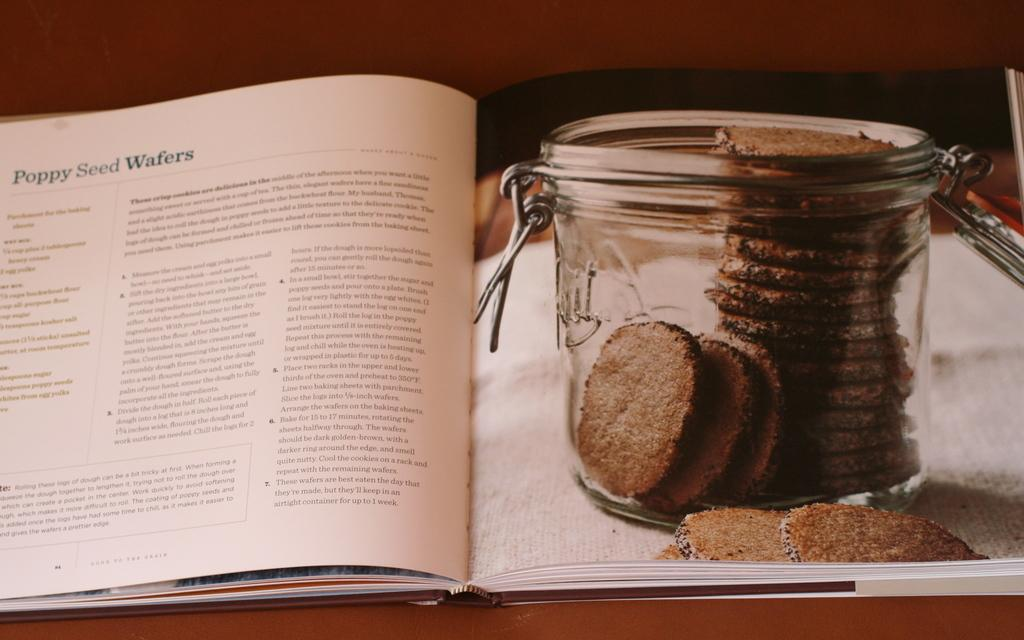<image>
Render a clear and concise summary of the photo. A cookbook opened to a recipe for poppy seed wafers. 